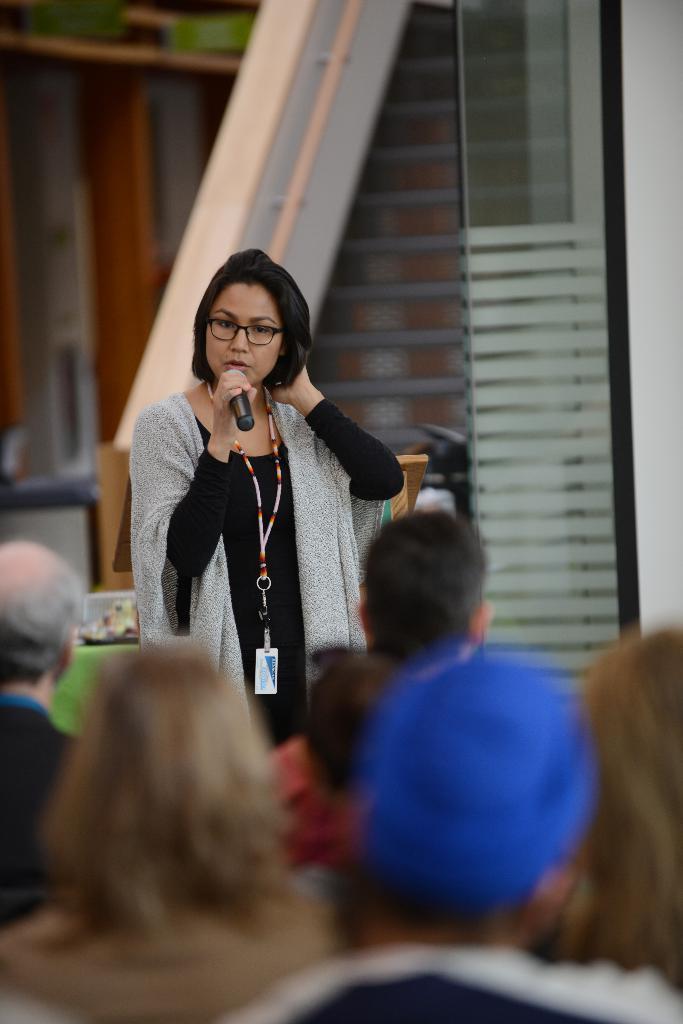In one or two sentences, can you explain what this image depicts? People are present. A woman is standing wearing an id card and holding a microphone. 